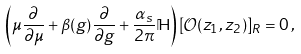<formula> <loc_0><loc_0><loc_500><loc_500>\left ( \mu \frac { \partial } { \partial \mu } + \beta ( g ) \frac { \partial } { \partial g } + \frac { \alpha _ { s } } { 2 \pi } \mathbb { H } \right ) [ \mathcal { O } ( z _ { 1 } , z _ { 2 } ) ] _ { R } = 0 \, ,</formula> 